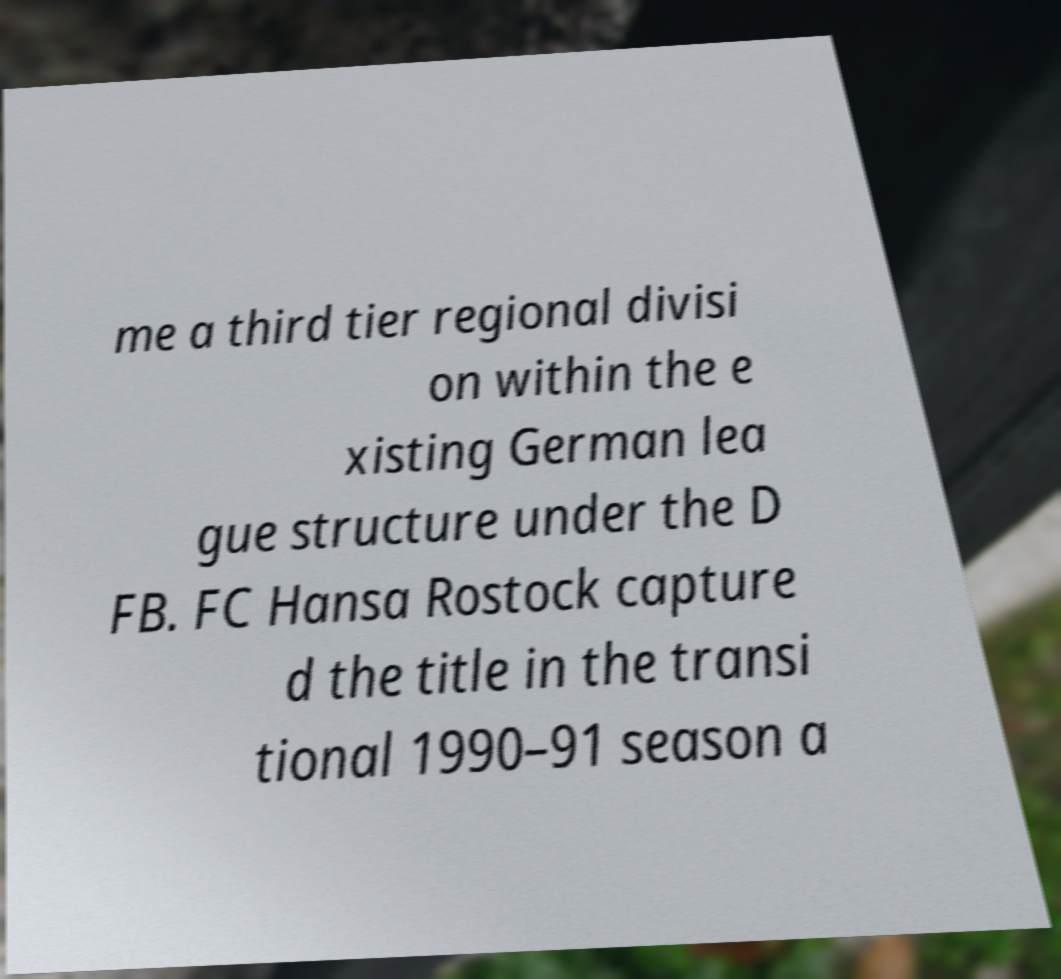There's text embedded in this image that I need extracted. Can you transcribe it verbatim? me a third tier regional divisi on within the e xisting German lea gue structure under the D FB. FC Hansa Rostock capture d the title in the transi tional 1990–91 season a 